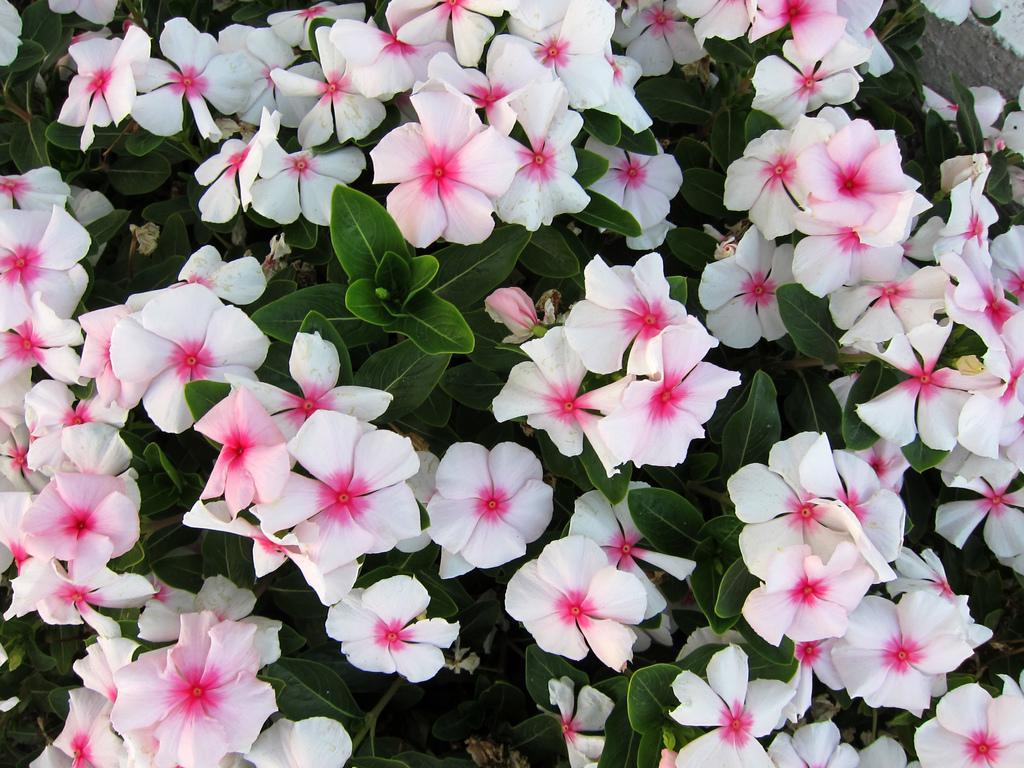Please provide a concise description of this image. In this image I can see white color flowers to a plant. The leaves are in green color. 